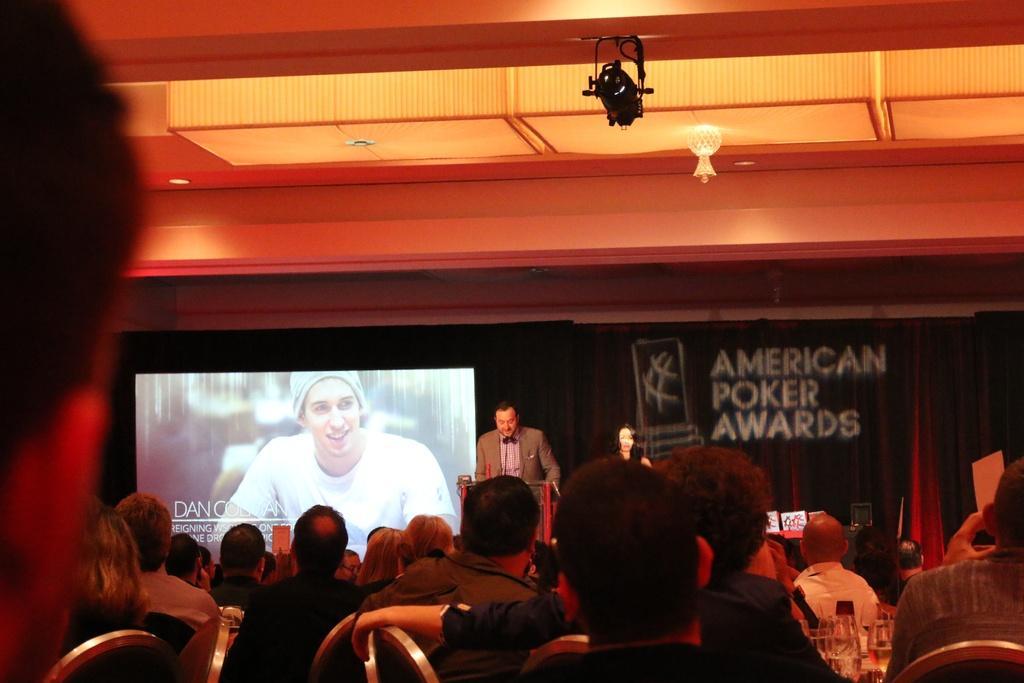Can you describe this image briefly? This image is taken indoors. At the bottom of the image many people are sitting on the chairs and there is a table with a few things on it. At the top of the image there is a ceiling with lights and there is a projector. In the background there is a poster with a text on it and there is a curtain. There is a projector screen with an image of a man and there is a text on it. A woman and a man are standing on the dais and there is a podium. 